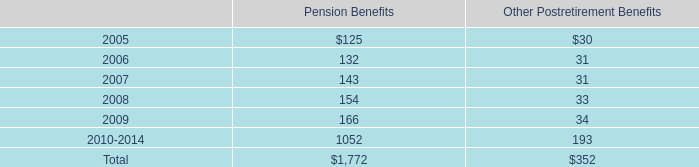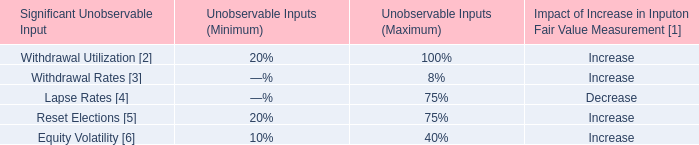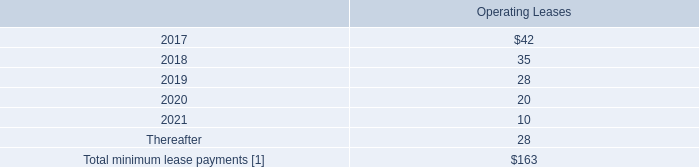what is the total future expected income from subleases? 
Computations: (((2 + 2) + 2) + 2)
Answer: 8.0. 